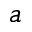<formula> <loc_0><loc_0><loc_500><loc_500>a</formula> 